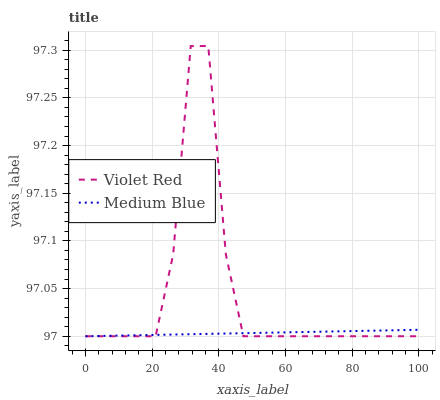Does Medium Blue have the maximum area under the curve?
Answer yes or no. No. Is Medium Blue the roughest?
Answer yes or no. No. Does Medium Blue have the highest value?
Answer yes or no. No. 